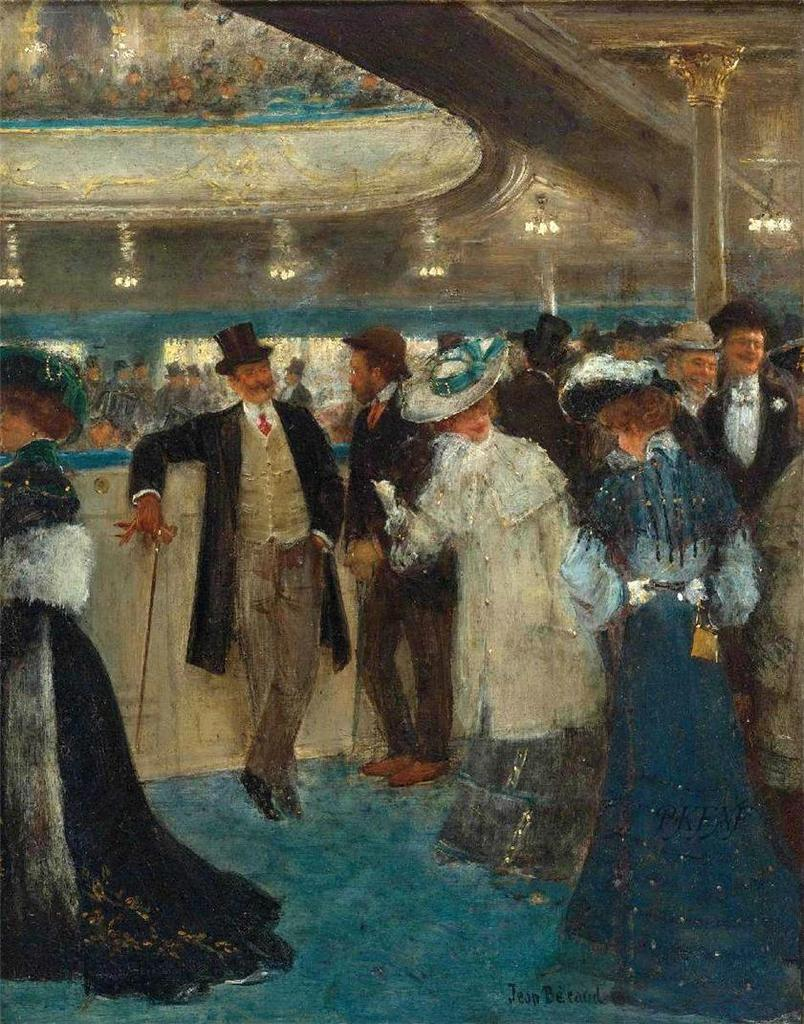What type of artwork is depicted in the image? The image is a painting. What subjects are featured in the painting? There are people in the painting. What are the people wearing in the painting? The people are wearing hats. What color is the surface in the painting? There is a blue surface in the painting. What type of toothbrush is being used by the people in the painting? There is no toothbrush present in the painting; the people are wearing hats. How many hands are visible in the painting? The provided facts do not mention hands, so it is impossible to determine the number of hands visible in the painting. 